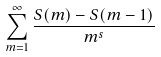<formula> <loc_0><loc_0><loc_500><loc_500>\sum _ { m = 1 } ^ { \infty } \frac { S ( m ) - S ( m - 1 ) } { m ^ { s } }</formula> 